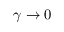Convert formula to latex. <formula><loc_0><loc_0><loc_500><loc_500>\gamma \rightarrow 0</formula> 